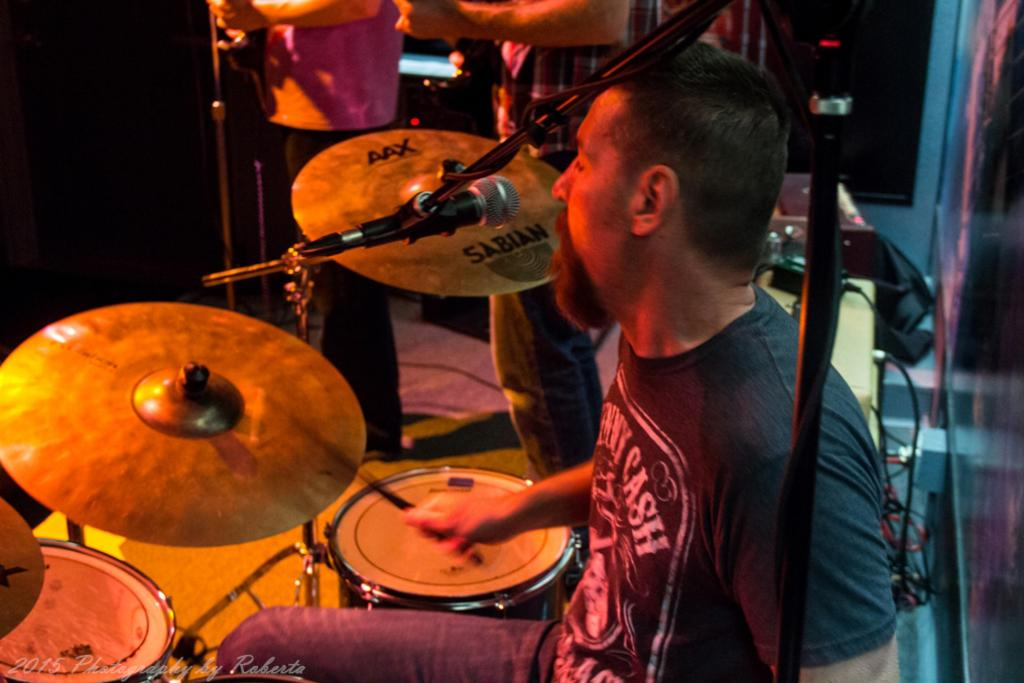What is the person in the image doing? The person is sitting and holding a stick in the image. What objects are related to music in the image? There are drums, a microphone, and two people holding musical instruments in the image. What is the person holding a stick likely to be using it for? The person holding a stick is likely using it as a conductor's baton, to direct the musicians. What structure is present in the image? There is a stand in the image. What is the person's digestion process like in the image? There is no information about the person's digestion process in the image. How much force is being applied to the bucket in the image? There is no bucket present in the image. 